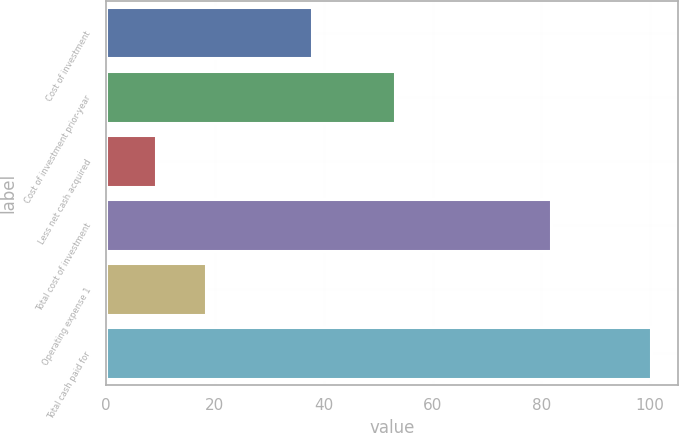<chart> <loc_0><loc_0><loc_500><loc_500><bar_chart><fcel>Cost of investment<fcel>Cost of investment prior-year<fcel>Less net cash acquired<fcel>Total cost of investment<fcel>Operating expense 1<fcel>Total cash paid for<nl><fcel>37.8<fcel>53.1<fcel>9.2<fcel>81.7<fcel>18.4<fcel>100.1<nl></chart> 